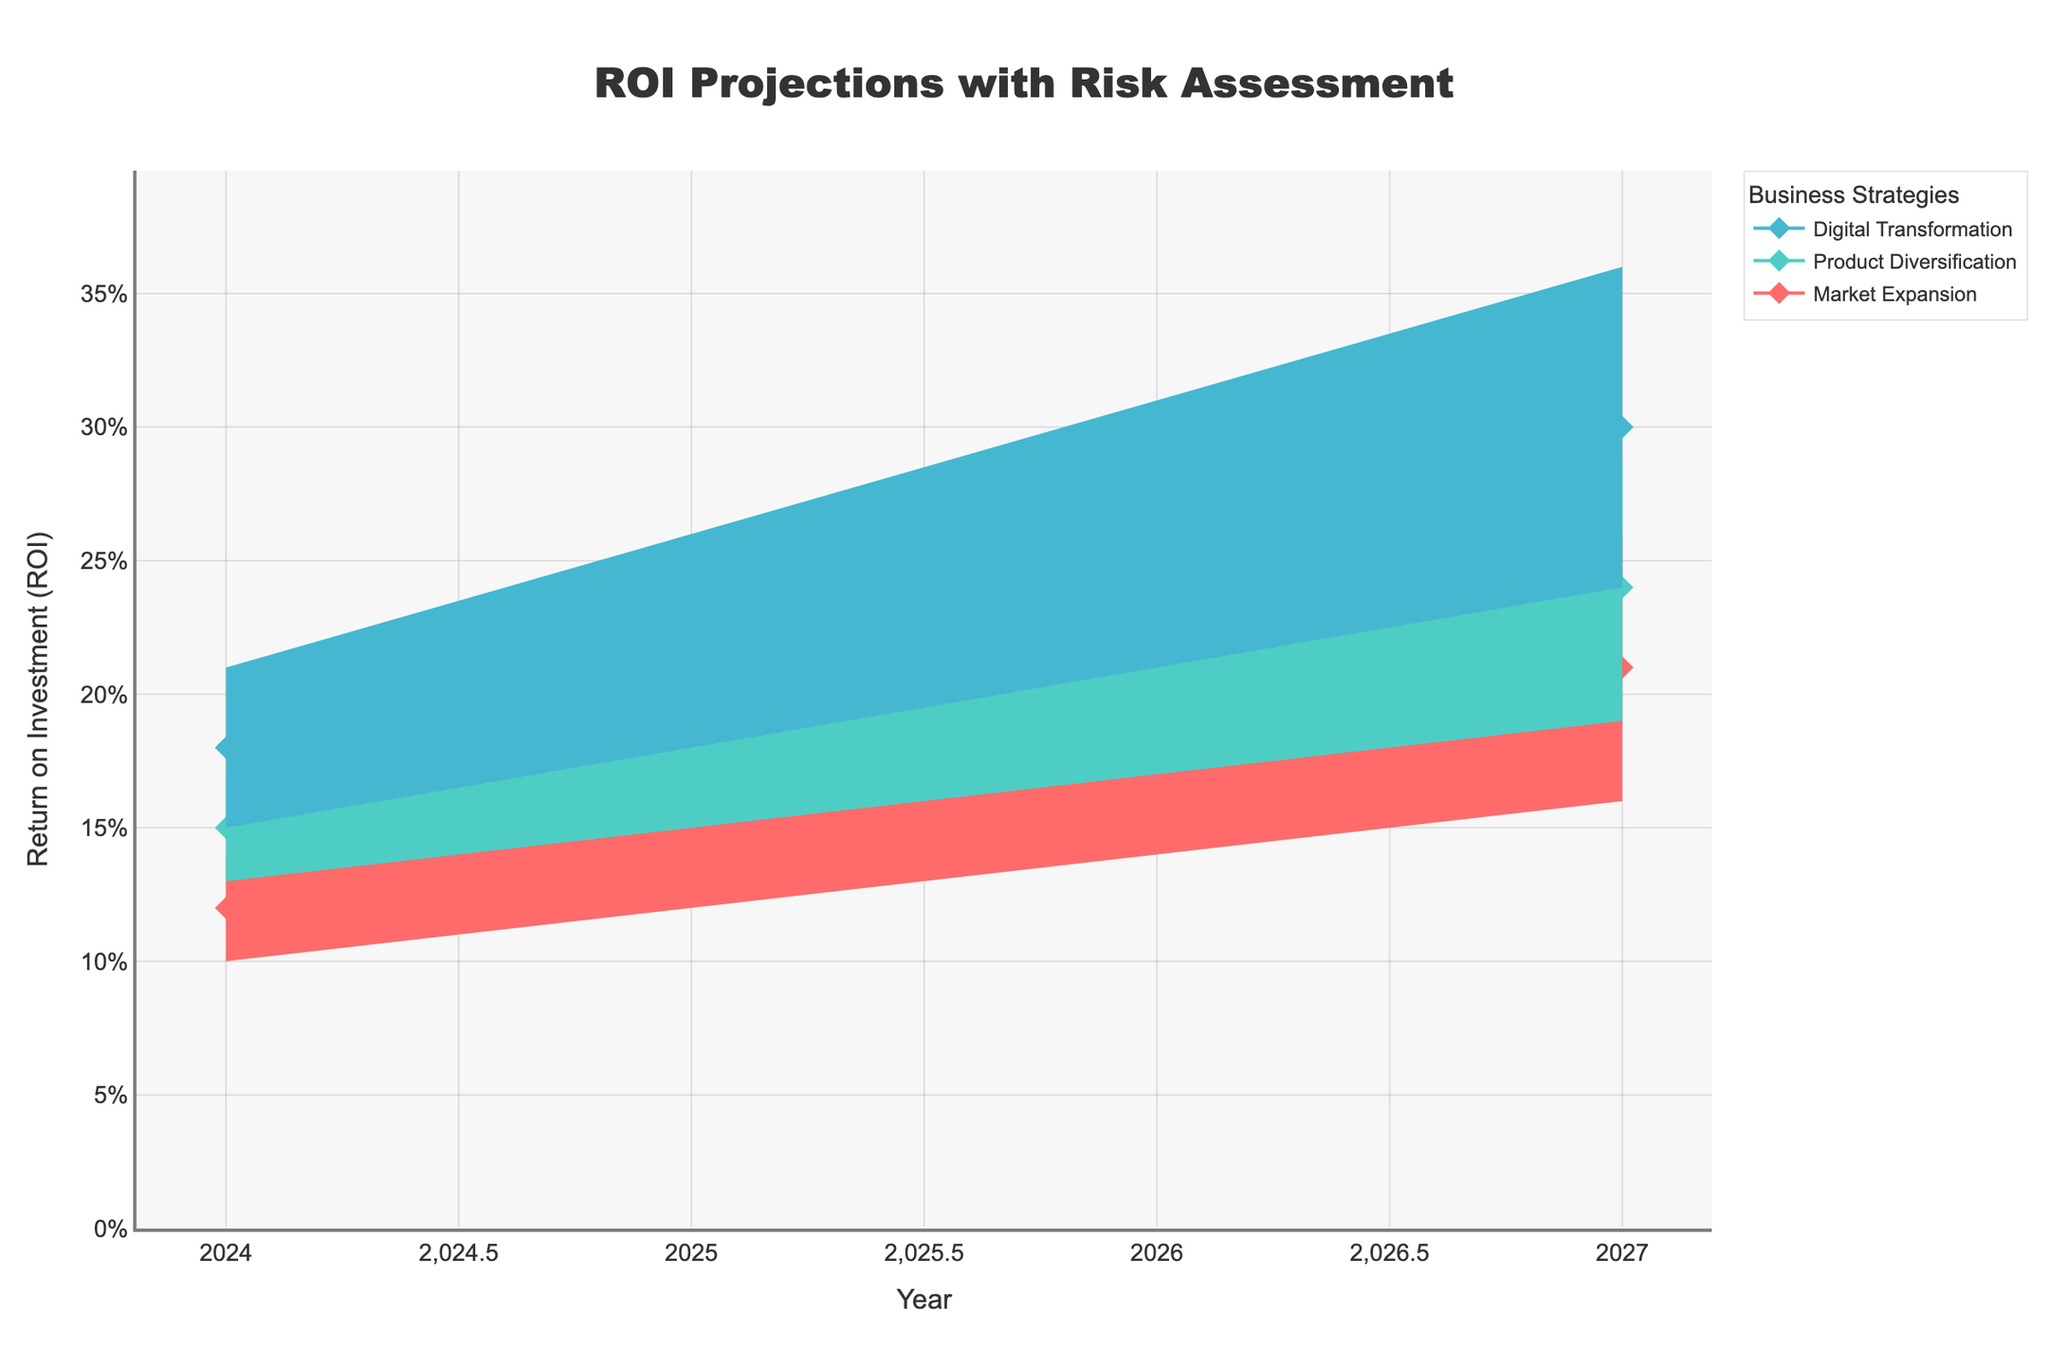What title is displayed at the top of the figure? The title can be found at the top of the figure, clearly visible and centered. In this case, it reads "ROI Projections with Risk Assessment" as specified in the code.
Answer: ROI Projections with Risk Assessment What is the projected ROI for Market Expansion in 2026? Locate the year 2026 on the x-axis and find the Projected ROI line for Market Expansion. The projected ROI is at the point where the line intersects the 2026 marker.
Answer: 18% Which business strategy shows the highest projected ROI in 2024? Compare the projected ROI of Market Expansion, Product Diversification, and Digital Transformation in 2024 by looking at the y-values of each strategy.
Answer: Digital Transformation What's the difference in projected ROI between Digital Transformation and Market Expansion in 2027? Find the projected ROI for both Digital Transformation and Market Expansion in 2027. Subtract the Market Expansion value (21%) from Digital Transformation value (30%).
Answer: 9% Between Product Diversification and Digital Transformation, which strategy has a higher ROI projection on average across all years? For each year (2024-2027), sum up the projected ROI for Product Diversification and divide by 4; similarly, sum up the projected ROI for Digital Transformation and divide by 4. Compare the averages.
Answer: Digital Transformation What are the low and high-risk ROI margins for Product Diversification in 2025? For Product Diversification in 2025, find the values at the lower and upper boundaries of the shaded area. These represent the low and high-risk ROIs.
Answer: 15%, 21% Which year shows the largest range between low and high-risk ROI for Digital Transformation? For each year, calculate the range (high-risk ROI - low-risk ROI) for Digital Transformation. Compare these ranges to find the largest.
Answer: 2027 How does the projected ROI for Market Expansion change from 2025 to 2026? Subtract the projected ROI for Market Expansion in 2025 (15%) from that in 2026 (18%).
Answer: It increases by 3% Which strategy remains the most stable across different risk levels? Evaluate the consistency of low, medium, and high risk ROIs for each strategy across all years. The strategy with the smallest fluctuations indicates greater stability.
Answer: Market Expansion What trend do you observe for Digital Transformation's projected ROI from 2024 to 2027? Examine the progression of the projected ROI for Digital Transformation from 2024 to 2027 on the y-axis. Note if it increases, decreases, or remains stable over the years.
Answer: Increasing 